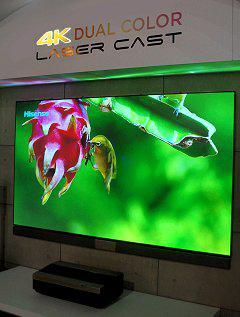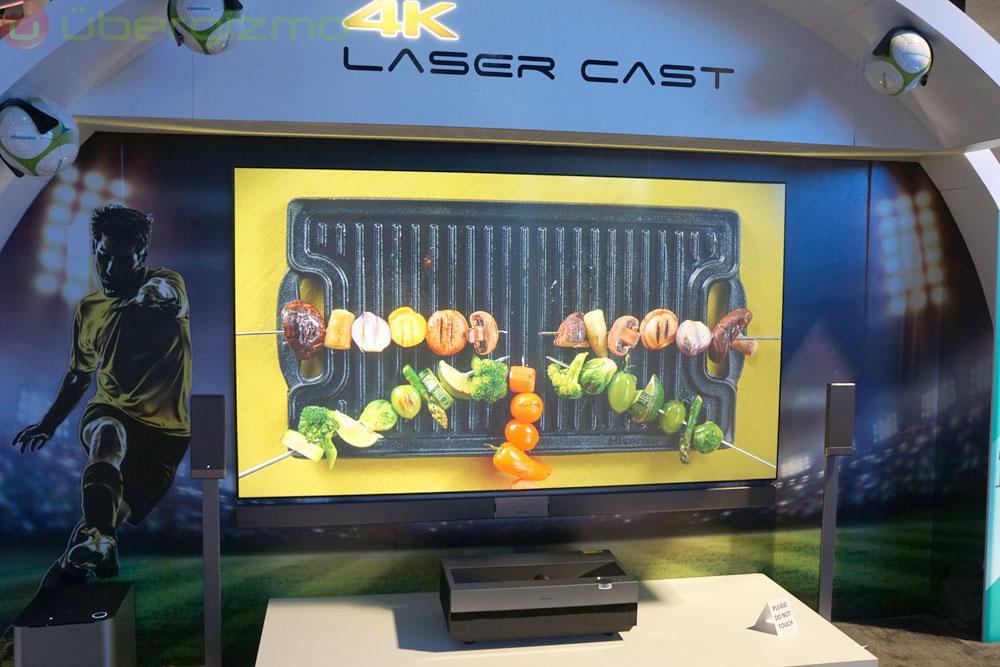The first image is the image on the left, the second image is the image on the right. Given the left and right images, does the statement "One of the television sets is showing a pink flower on a green background." hold true? Answer yes or no. Yes. The first image is the image on the left, the second image is the image on the right. Analyze the images presented: Is the assertion "In at least one image you can see a green background and a hummingbird on the tv that is below gold lettering." valid? Answer yes or no. Yes. 